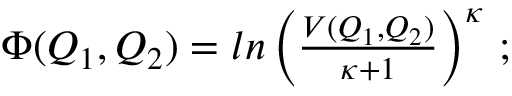<formula> <loc_0><loc_0><loc_500><loc_500>\begin{array} { r } { \Phi ( Q _ { 1 } , Q _ { 2 } ) = \ln \left ( \frac { V ( Q _ { 1 } , Q _ { 2 } ) } { \kappa + 1 } \right ) ^ { \kappa } \, ; } \end{array}</formula> 